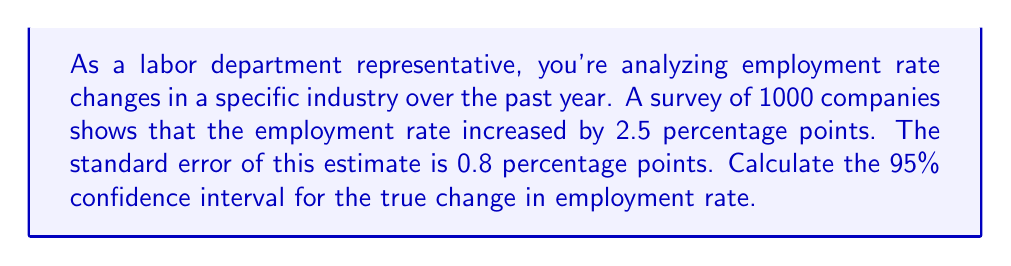Can you solve this math problem? To calculate the 95% confidence interval, we'll follow these steps:

1. Identify the point estimate: 2.5 percentage points
2. Determine the standard error: 0.8 percentage points
3. Find the critical value for a 95% confidence level: 1.96 (assuming a normal distribution)
4. Calculate the margin of error
5. Construct the confidence interval

Step 1: Point estimate = 2.5 percentage points

Step 2: Standard error = 0.8 percentage points

Step 3: For a 95% confidence level, the critical value is 1.96

Step 4: Calculate the margin of error
$$ \text{Margin of Error} = \text{Critical Value} \times \text{Standard Error} $$
$$ \text{Margin of Error} = 1.96 \times 0.8 = 1.568 \text{ percentage points} $$

Step 5: Construct the confidence interval
$$ \text{Confidence Interval} = \text{Point Estimate} \pm \text{Margin of Error} $$
$$ \text{Lower Bound} = 2.5 - 1.568 = 0.932 \text{ percentage points} $$
$$ \text{Upper Bound} = 2.5 + 1.568 = 4.068 \text{ percentage points} $$

Therefore, the 95% confidence interval for the true change in employment rate is (0.932, 4.068) percentage points.
Answer: (0.932, 4.068) percentage points 